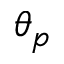<formula> <loc_0><loc_0><loc_500><loc_500>\theta _ { p }</formula> 